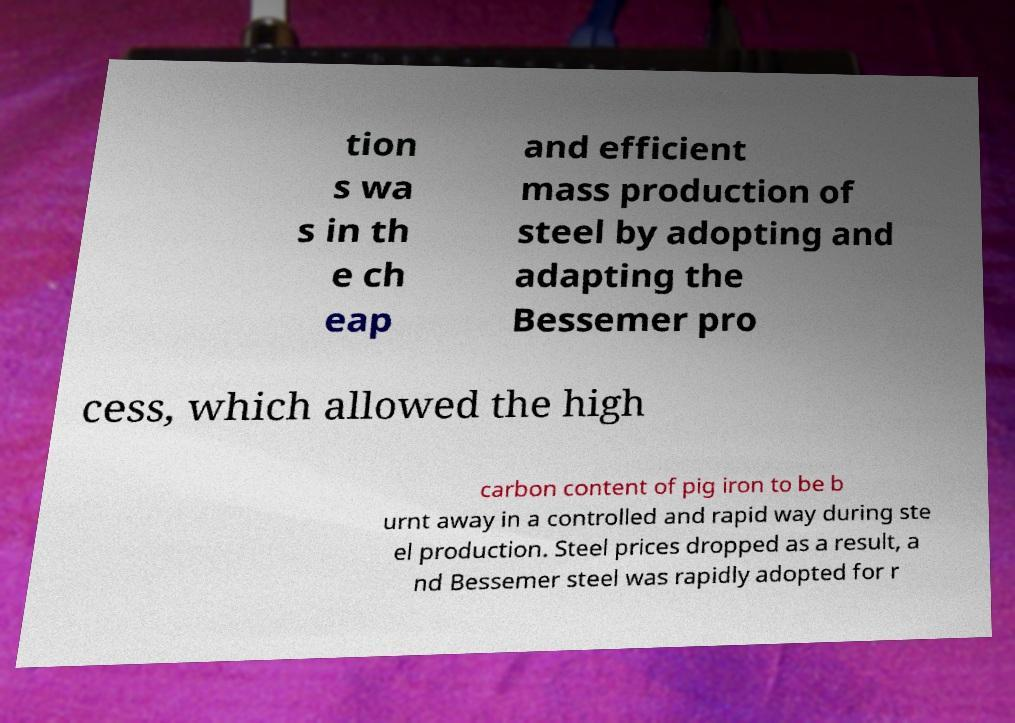I need the written content from this picture converted into text. Can you do that? tion s wa s in th e ch eap and efficient mass production of steel by adopting and adapting the Bessemer pro cess, which allowed the high carbon content of pig iron to be b urnt away in a controlled and rapid way during ste el production. Steel prices dropped as a result, a nd Bessemer steel was rapidly adopted for r 